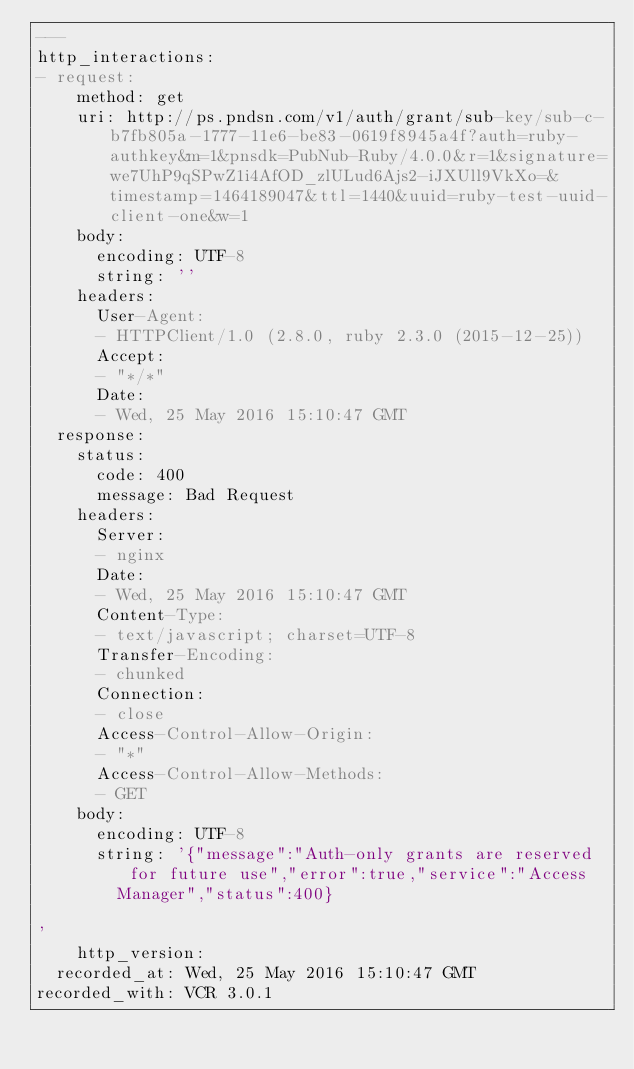Convert code to text. <code><loc_0><loc_0><loc_500><loc_500><_YAML_>---
http_interactions:
- request:
    method: get
    uri: http://ps.pndsn.com/v1/auth/grant/sub-key/sub-c-b7fb805a-1777-11e6-be83-0619f8945a4f?auth=ruby-authkey&m=1&pnsdk=PubNub-Ruby/4.0.0&r=1&signature=we7UhP9qSPwZ1i4AfOD_zlULud6Ajs2-iJXUll9VkXo=&timestamp=1464189047&ttl=1440&uuid=ruby-test-uuid-client-one&w=1
    body:
      encoding: UTF-8
      string: ''
    headers:
      User-Agent:
      - HTTPClient/1.0 (2.8.0, ruby 2.3.0 (2015-12-25))
      Accept:
      - "*/*"
      Date:
      - Wed, 25 May 2016 15:10:47 GMT
  response:
    status:
      code: 400
      message: Bad Request
    headers:
      Server:
      - nginx
      Date:
      - Wed, 25 May 2016 15:10:47 GMT
      Content-Type:
      - text/javascript; charset=UTF-8
      Transfer-Encoding:
      - chunked
      Connection:
      - close
      Access-Control-Allow-Origin:
      - "*"
      Access-Control-Allow-Methods:
      - GET
    body:
      encoding: UTF-8
      string: '{"message":"Auth-only grants are reserved for future use","error":true,"service":"Access
        Manager","status":400}

'
    http_version: 
  recorded_at: Wed, 25 May 2016 15:10:47 GMT
recorded_with: VCR 3.0.1
</code> 